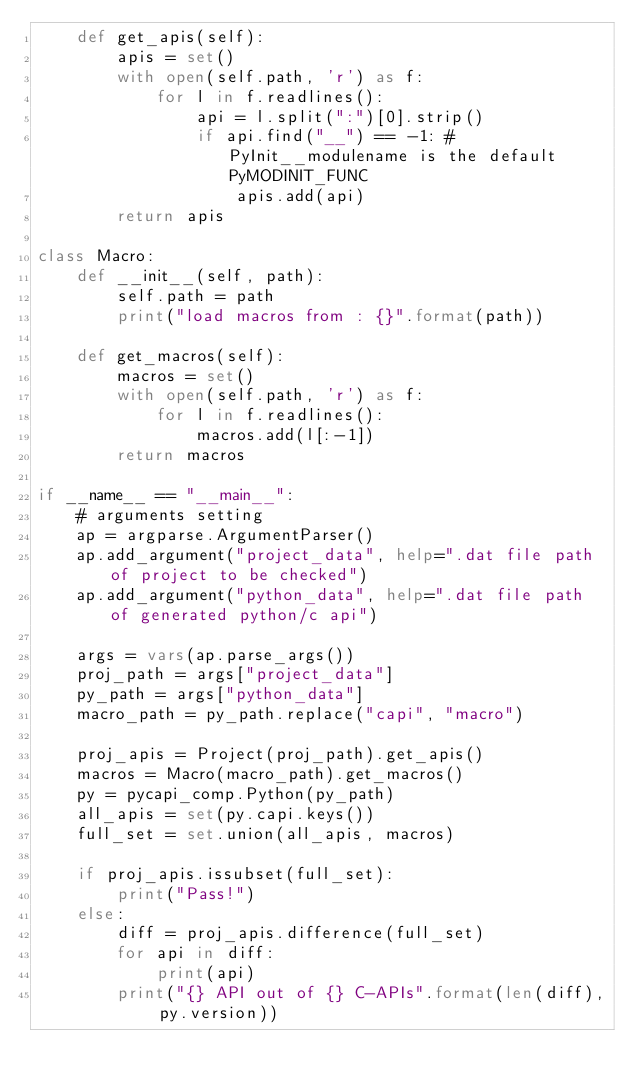<code> <loc_0><loc_0><loc_500><loc_500><_Python_>    def get_apis(self):
        apis = set()
        with open(self.path, 'r') as f:
            for l in f.readlines():
                api = l.split(":")[0].strip()
                if api.find("__") == -1: # PyInit__modulename is the default PyMODINIT_FUNC
                    apis.add(api)
        return apis

class Macro:
    def __init__(self, path):
        self.path = path
        print("load macros from : {}".format(path))

    def get_macros(self):
        macros = set()
        with open(self.path, 'r') as f:
            for l in f.readlines():
                macros.add(l[:-1])
        return macros

if __name__ == "__main__":
    # arguments setting
    ap = argparse.ArgumentParser()
    ap.add_argument("project_data", help=".dat file path of project to be checked")
    ap.add_argument("python_data", help=".dat file path of generated python/c api")

    args = vars(ap.parse_args())
    proj_path = args["project_data"]
    py_path = args["python_data"]
    macro_path = py_path.replace("capi", "macro")
            
    proj_apis = Project(proj_path).get_apis()
    macros = Macro(macro_path).get_macros()
    py = pycapi_comp.Python(py_path)
    all_apis = set(py.capi.keys())
    full_set = set.union(all_apis, macros)

    if proj_apis.issubset(full_set):
        print("Pass!")
    else:
        diff = proj_apis.difference(full_set)
        for api in diff:
            print(api)
        print("{} API out of {} C-APIs".format(len(diff), py.version))
</code> 